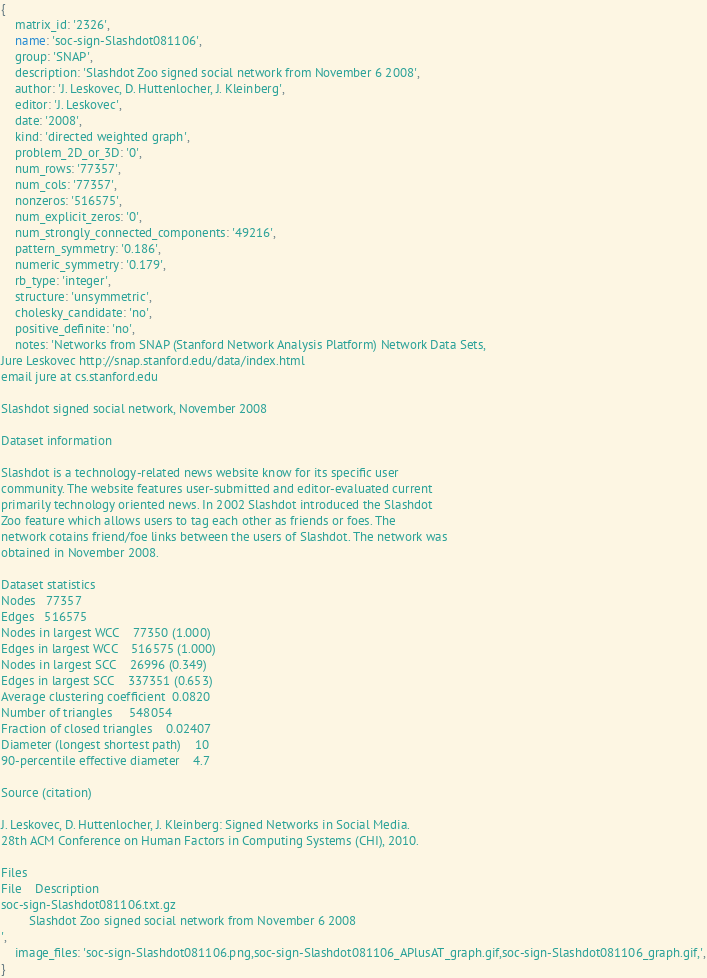Convert code to text. <code><loc_0><loc_0><loc_500><loc_500><_Ruby_>{
    matrix_id: '2326',
    name: 'soc-sign-Slashdot081106',
    group: 'SNAP',
    description: 'Slashdot Zoo signed social network from November 6 2008',
    author: 'J. Leskovec, D. Huttenlocher, J. Kleinberg',
    editor: 'J. Leskovec',
    date: '2008',
    kind: 'directed weighted graph',
    problem_2D_or_3D: '0',
    num_rows: '77357',
    num_cols: '77357',
    nonzeros: '516575',
    num_explicit_zeros: '0',
    num_strongly_connected_components: '49216',
    pattern_symmetry: '0.186',
    numeric_symmetry: '0.179',
    rb_type: 'integer',
    structure: 'unsymmetric',
    cholesky_candidate: 'no',
    positive_definite: 'no',
    notes: 'Networks from SNAP (Stanford Network Analysis Platform) Network Data Sets,     
Jure Leskovec http://snap.stanford.edu/data/index.html                         
email jure at cs.stanford.edu                                                  
                                                                               
Slashdot signed social network, November 2008                                  
                                                                               
Dataset information                                                            
                                                                               
Slashdot is a technology-related news website know for its specific user       
community. The website features user-submitted and editor-evaluated current    
primarily technology oriented news. In 2002 Slashdot introduced the Slashdot   
Zoo feature which allows users to tag each other as friends or foes. The       
network cotains friend/foe links between the users of Slashdot. The network was
obtained in November 2008.                                                     
                                                                               
Dataset statistics                                                             
Nodes   77357                                                                  
Edges   516575                                                                 
Nodes in largest WCC    77350 (1.000)                                          
Edges in largest WCC    516575 (1.000)                                         
Nodes in largest SCC    26996 (0.349)                                          
Edges in largest SCC    337351 (0.653)                                         
Average clustering coefficient  0.0820                                         
Number of triangles     548054                                                 
Fraction of closed triangles    0.02407                                        
Diameter (longest shortest path)    10                                         
90-percentile effective diameter    4.7                                        
                                                                               
Source (citation)                                                              
                                                                               
J. Leskovec, D. Huttenlocher, J. Kleinberg: Signed Networks in Social Media.   
28th ACM Conference on Human Factors in Computing Systems (CHI), 2010.         
                                                                               
Files                                                                          
File    Description                                                            
soc-sign-Slashdot081106.txt.gz                                                 
        Slashdot Zoo signed social network from November 6 2008                
',
    image_files: 'soc-sign-Slashdot081106.png,soc-sign-Slashdot081106_APlusAT_graph.gif,soc-sign-Slashdot081106_graph.gif,',
}
</code> 